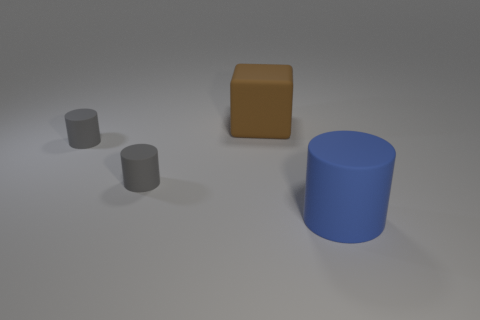Subtract all gray matte cylinders. How many cylinders are left? 1 Subtract all blue cylinders. How many cylinders are left? 2 Add 4 small objects. How many objects exist? 8 Subtract 1 cubes. How many cubes are left? 0 Subtract 0 red blocks. How many objects are left? 4 Subtract all cubes. How many objects are left? 3 Subtract all purple blocks. Subtract all yellow cylinders. How many blocks are left? 1 Subtract all red cubes. How many gray cylinders are left? 2 Subtract all brown cubes. Subtract all large rubber things. How many objects are left? 1 Add 1 big blue matte objects. How many big blue matte objects are left? 2 